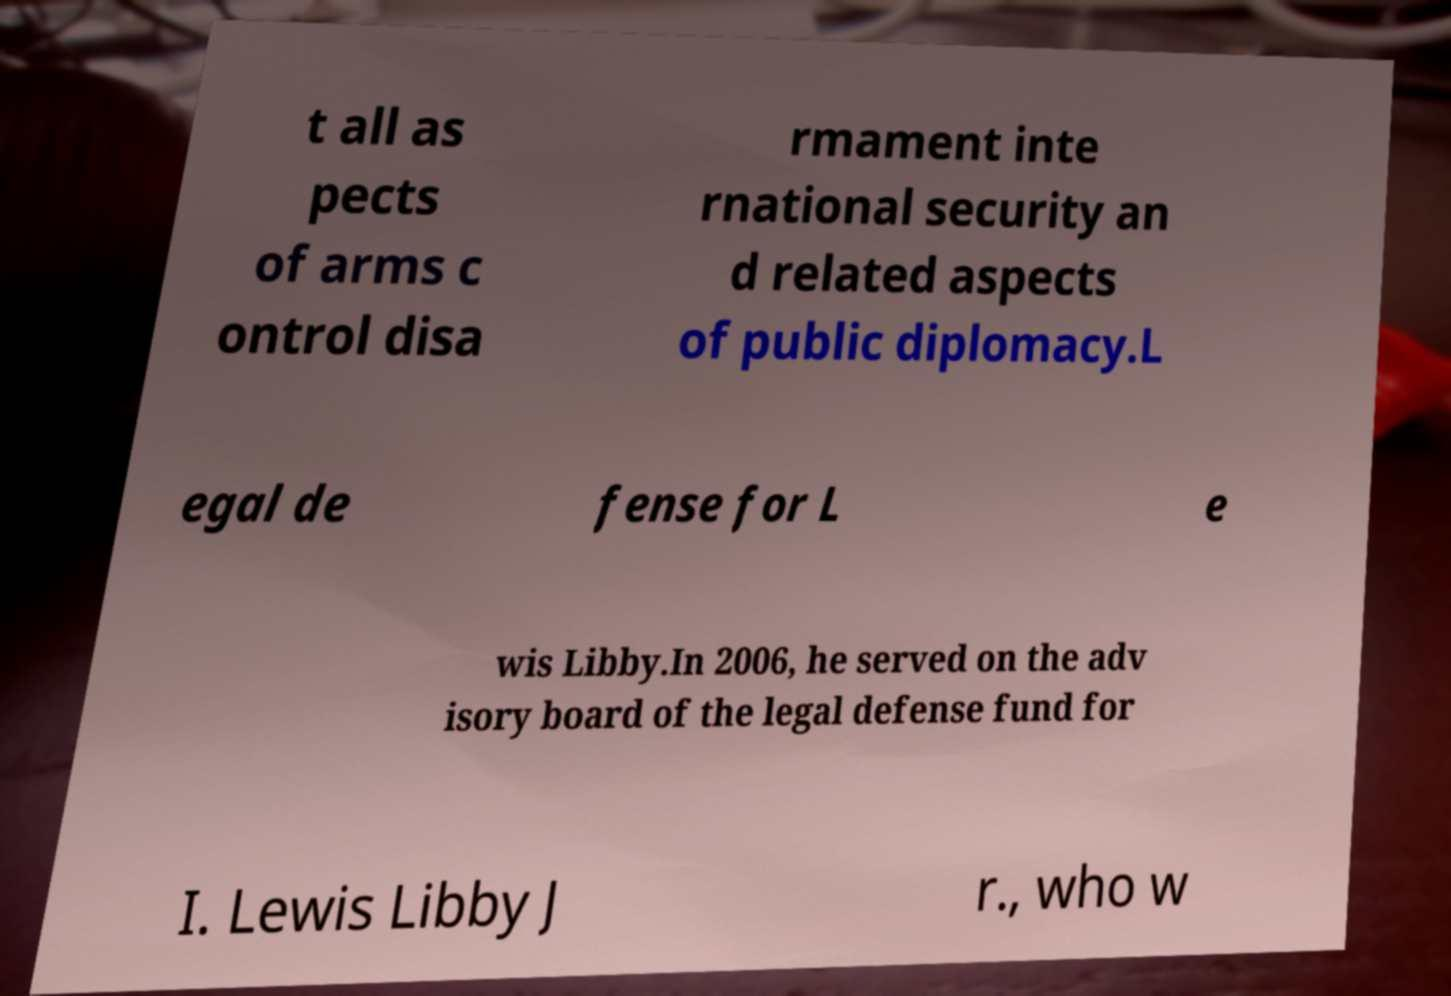For documentation purposes, I need the text within this image transcribed. Could you provide that? t all as pects of arms c ontrol disa rmament inte rnational security an d related aspects of public diplomacy.L egal de fense for L e wis Libby.In 2006, he served on the adv isory board of the legal defense fund for I. Lewis Libby J r., who w 